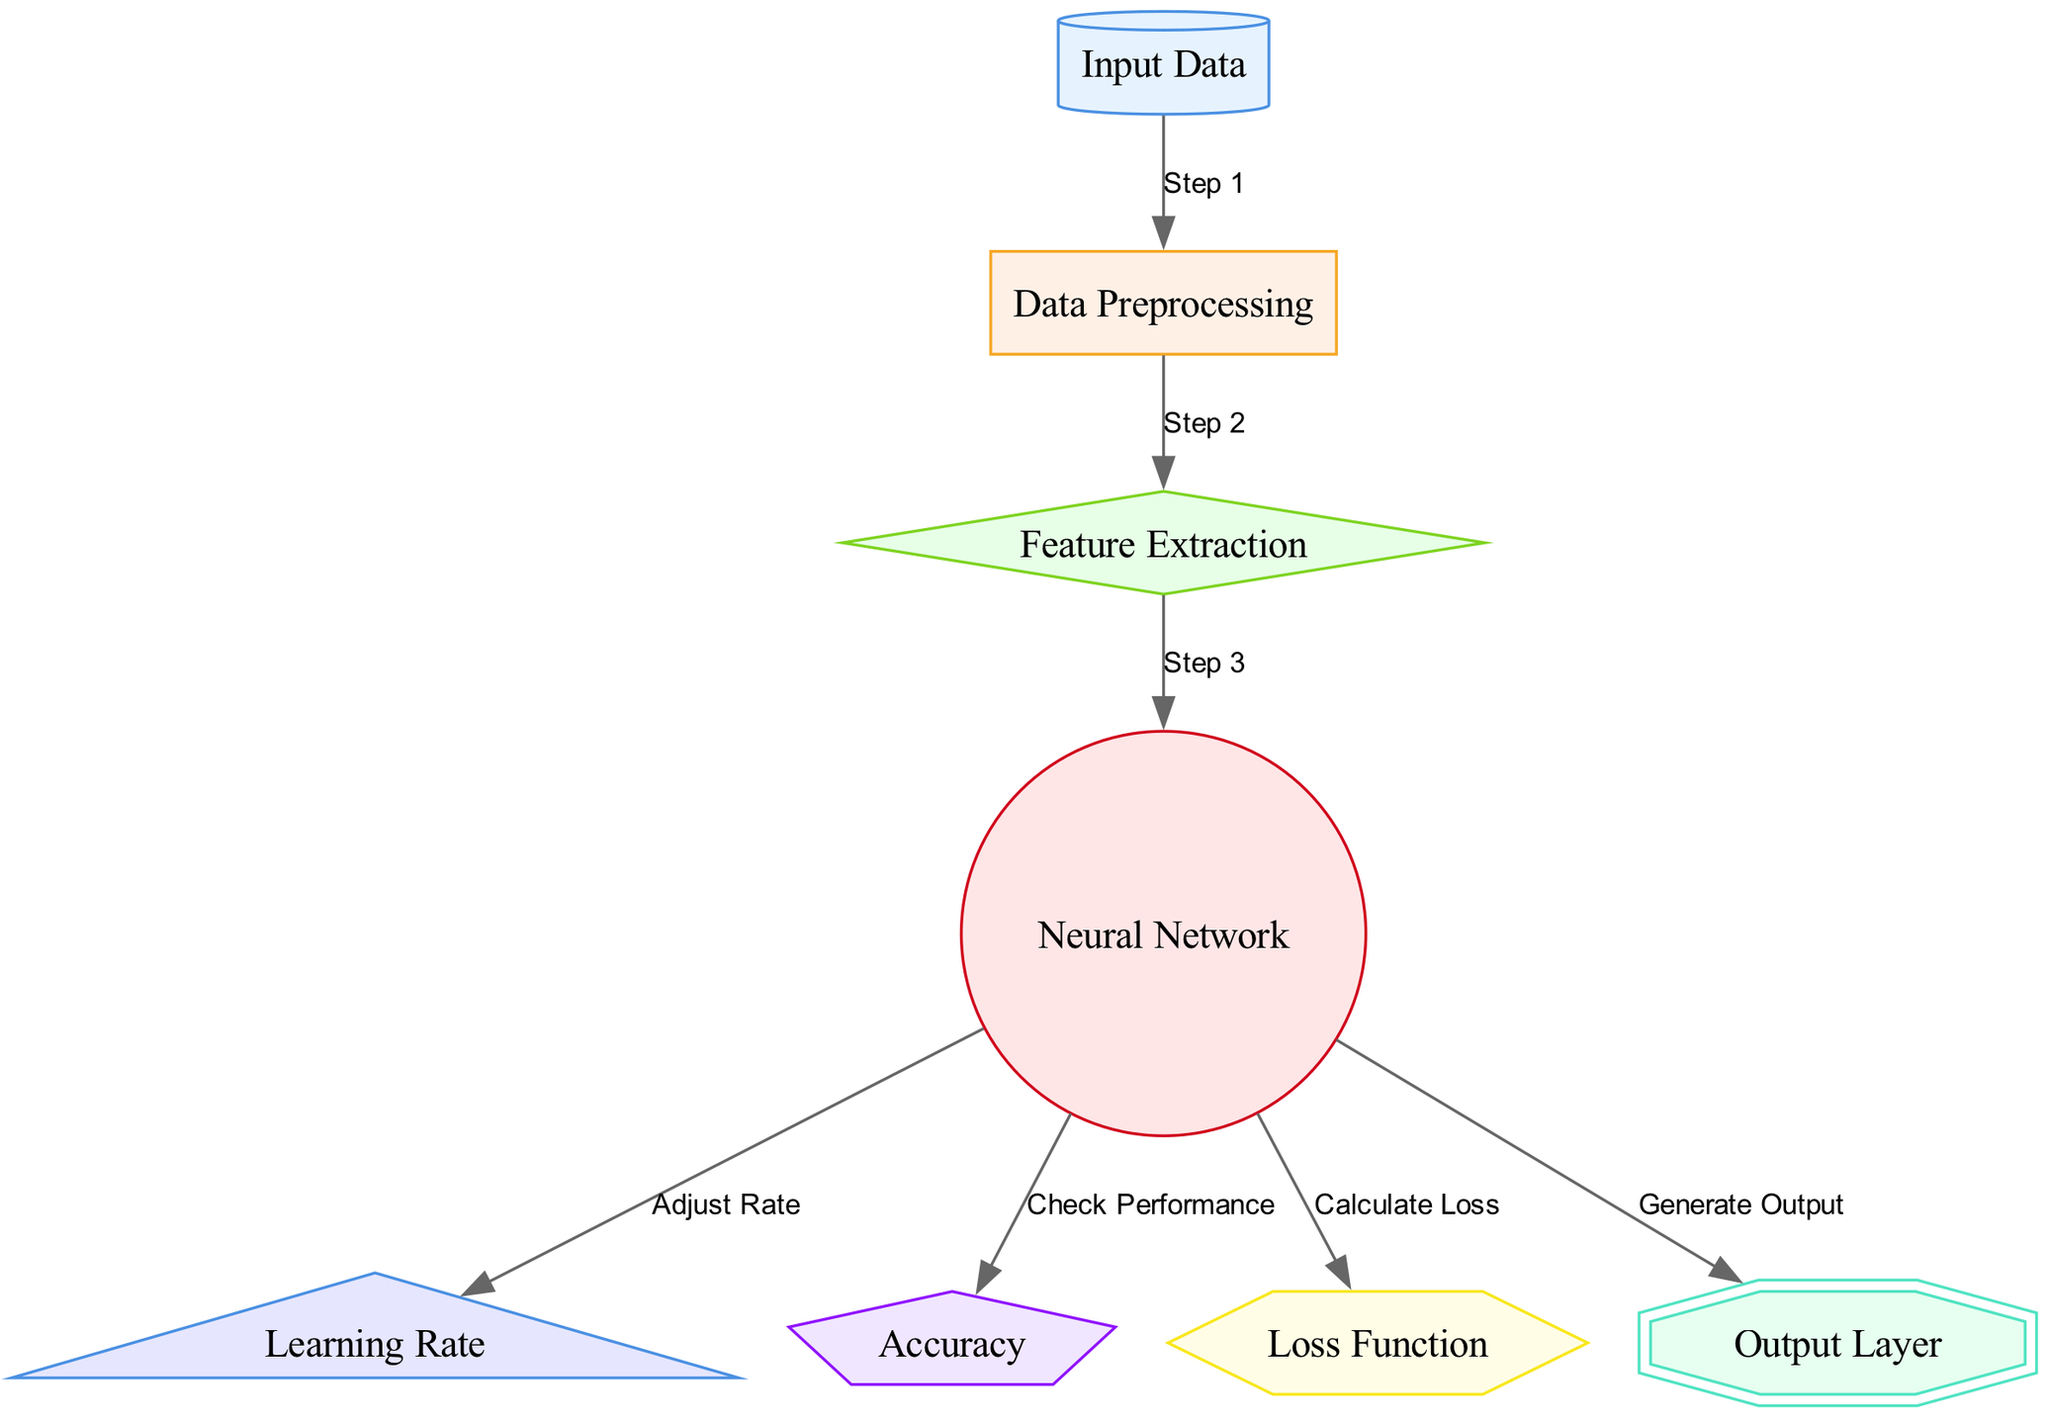What is the first step in the diagram? The diagram indicates that the first step is to process input_data, as shown by the arrow leading from input_data to data_preprocessing labeled "Step 1."
Answer: Input Data How many nodes are present in the diagram? By counting the nodes listed in the data, we see eight distinct nodes: input_data, data_preprocessing, feature_extraction, neural_network, learning_rate, accuracy, loss_function, and output_layer.
Answer: Eight What action follows feature extraction? Following the feature extraction node, the next node in the diagram is neural_network, indicating that feature extraction leads directly to the neural network processing.
Answer: Neural Network What is the shape of the output layer? The output layer is represented as a double octagon according to the node styles specified for the output_layer.
Answer: Double Octagon How does the neural network check its performance? The neural network checks its performance by connecting to the accuracy node, as indicated by the edge labeled "Check Performance" leading from neural_network to accuracy.
Answer: Check Performance In what context is the learning rate adjusted? The learning rate is adjusted after the neural network has been processed, as shown by the arrow leading from neural_network to learning_rate labeled "Adjust Rate."
Answer: Neural Network What type of function is calculated in the diagram? The diagram specifies that a loss function is calculated as indicated by the edge from neural_network to loss_function labeled "Calculate Loss."
Answer: Loss Function Which step immediately follows data preprocessing? The step that immediately follows data preprocessing is feature extraction, as indicated by the edge connecting data_preprocessing to feature_extraction labeled "Step 2."
Answer: Feature Extraction 